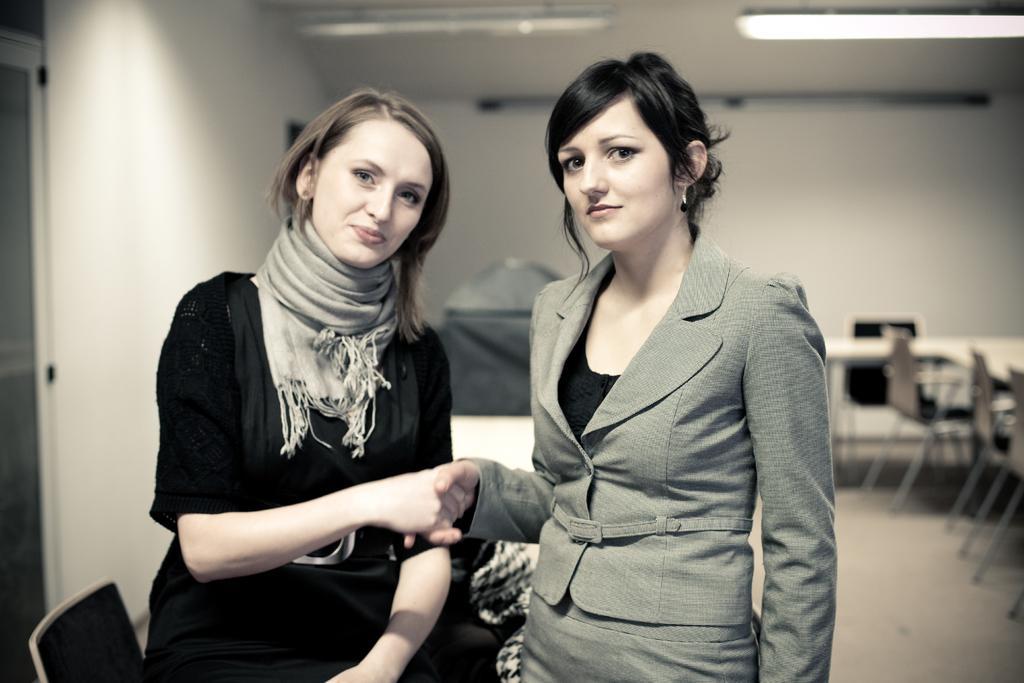Please provide a concise description of this image. On the left side a beautiful woman is shaking hands, she wore black color dress. On the right side there is another woman, she wore coat. 